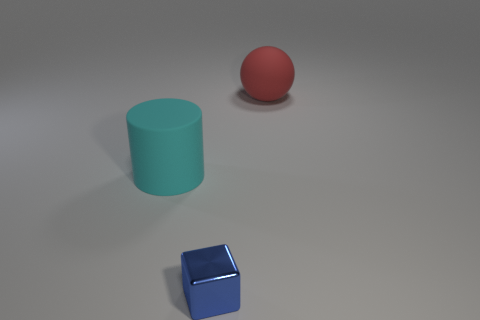Is there anything else that is the same material as the small blue object?
Ensure brevity in your answer.  No. There is a red thing that is behind the tiny blue metallic object; what material is it?
Give a very brief answer. Rubber. How many purple objects are either big things or tiny cubes?
Your answer should be very brief. 0. Are there more big cyan matte cylinders than matte things?
Provide a short and direct response. No. Do the thing left of the blue metal block and the object that is in front of the rubber cylinder have the same size?
Provide a succinct answer. No. There is a matte thing that is to the right of the big matte object that is to the left of the large thing that is on the right side of the cyan thing; what color is it?
Make the answer very short. Red. Are there more large cyan objects behind the small object than tiny gray things?
Provide a short and direct response. Yes. How many metallic objects are either red balls or cyan cylinders?
Your response must be concise. 0. How big is the thing that is to the right of the large cyan cylinder and in front of the big red rubber thing?
Your response must be concise. Small. There is a big matte thing in front of the red sphere; is there a big thing behind it?
Ensure brevity in your answer.  Yes. 